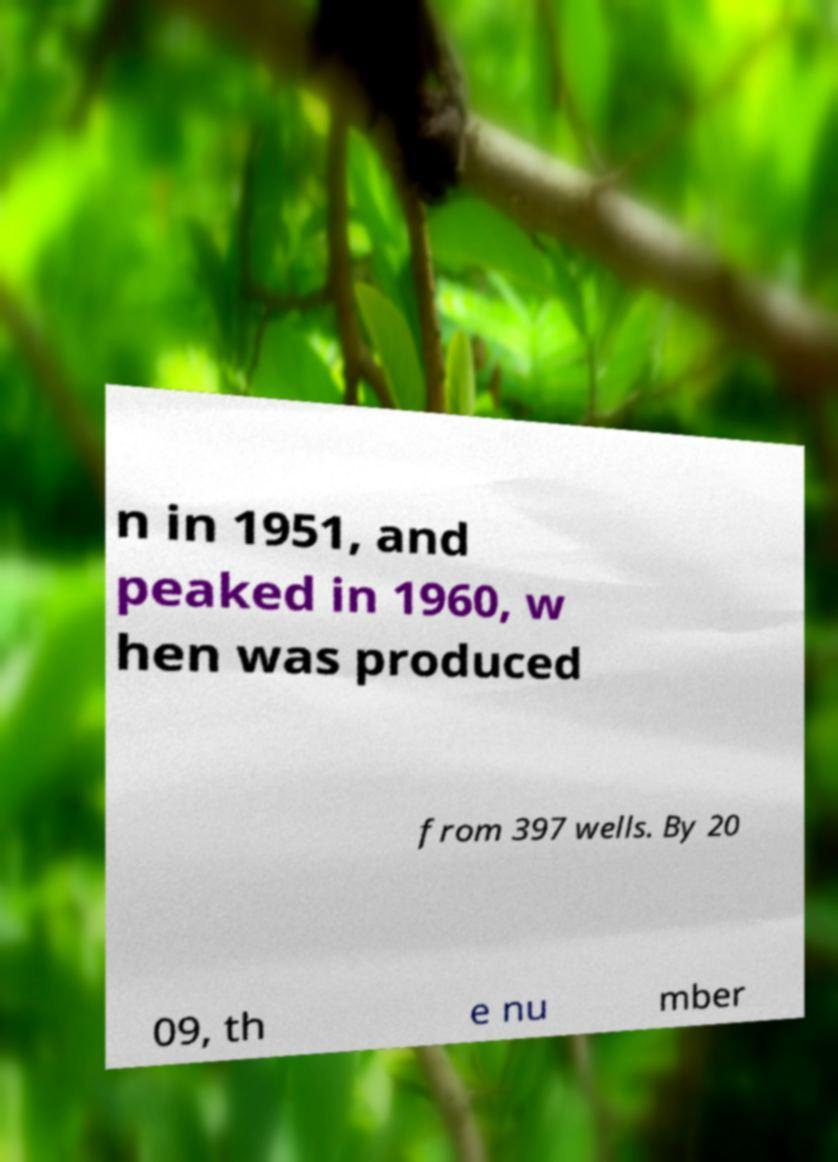Please identify and transcribe the text found in this image. n in 1951, and peaked in 1960, w hen was produced from 397 wells. By 20 09, th e nu mber 